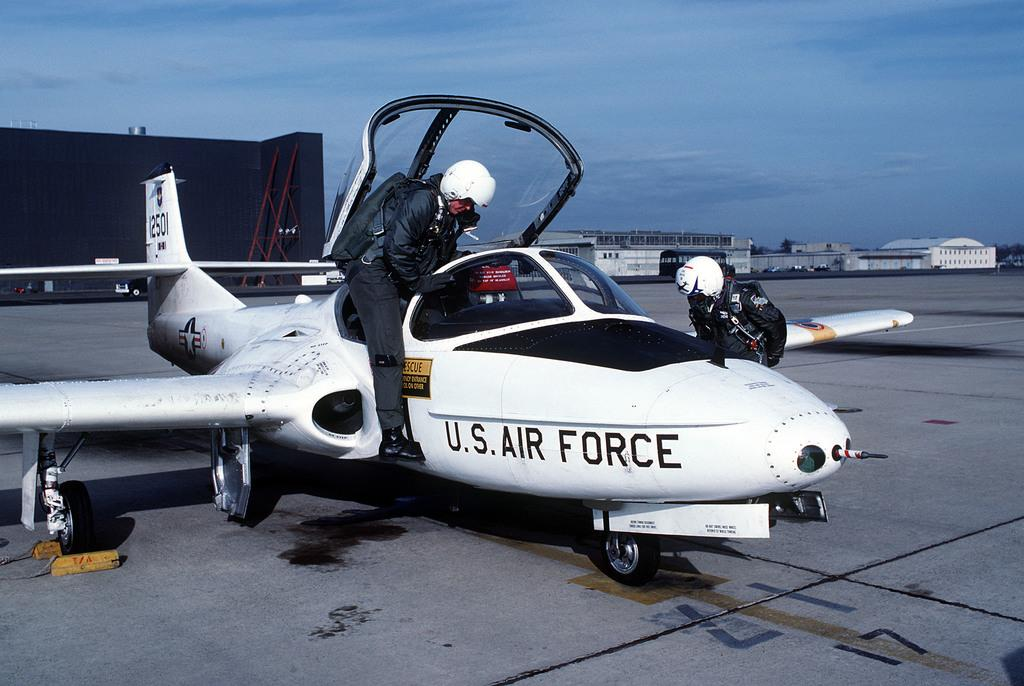<image>
Render a clear and concise summary of the photo. U.S Air Force airplane with a rescue sign and a logo with a star. 